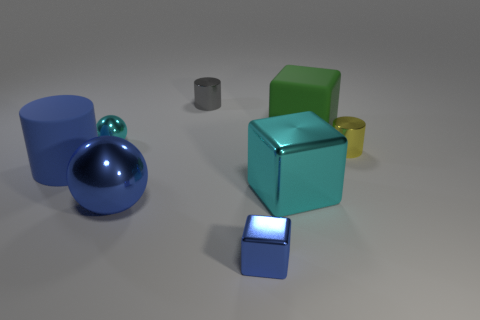What number of other objects are there of the same shape as the tiny gray thing?
Make the answer very short. 2. What material is the thing that is to the left of the small gray cylinder and in front of the large cyan thing?
Provide a short and direct response. Metal. What number of things are either small purple cubes or large metallic objects?
Offer a very short reply. 2. Are there more small purple metallic balls than green things?
Ensure brevity in your answer.  No. There is a yellow cylinder that is to the right of the large rubber object that is to the right of the blue metal cube; what is its size?
Provide a succinct answer. Small. What color is the big thing that is the same shape as the small yellow metallic thing?
Your answer should be very brief. Blue. What size is the cyan shiny block?
Offer a very short reply. Large. How many balls are cyan rubber objects or green matte objects?
Provide a succinct answer. 0. There is a green thing that is the same shape as the small blue object; what size is it?
Keep it short and to the point. Large. How many large cyan cubes are there?
Offer a terse response. 1. 